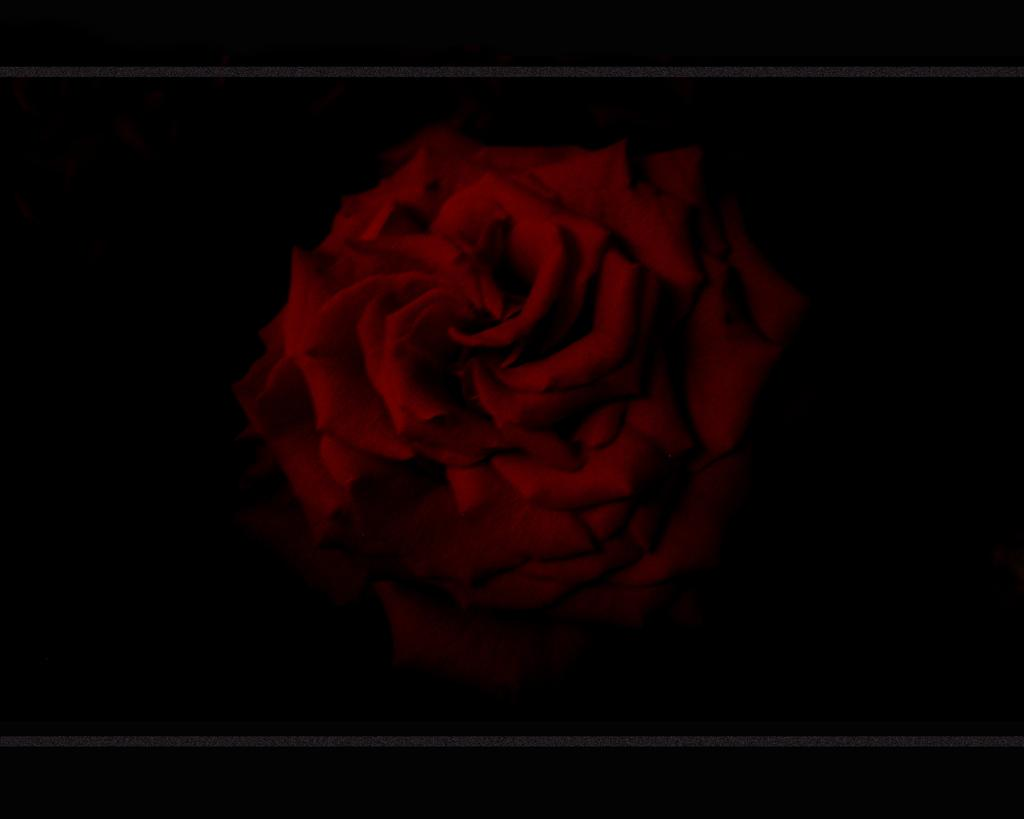What type of flower is in the image? There is a red color rose flower in the image. Where is the flower located in the image? The flower is in the middle of the image. What is the color of the background in the image? The background of the image is dark. Can you see any feathers attached to the rose flower in the image? There are no feathers present or attached to the rose flower in the image. What type of rice is being cooked in the background of the image? There is no rice visible or mentioned in the image; it only features a red color rose flower in the middle and a dark background. 